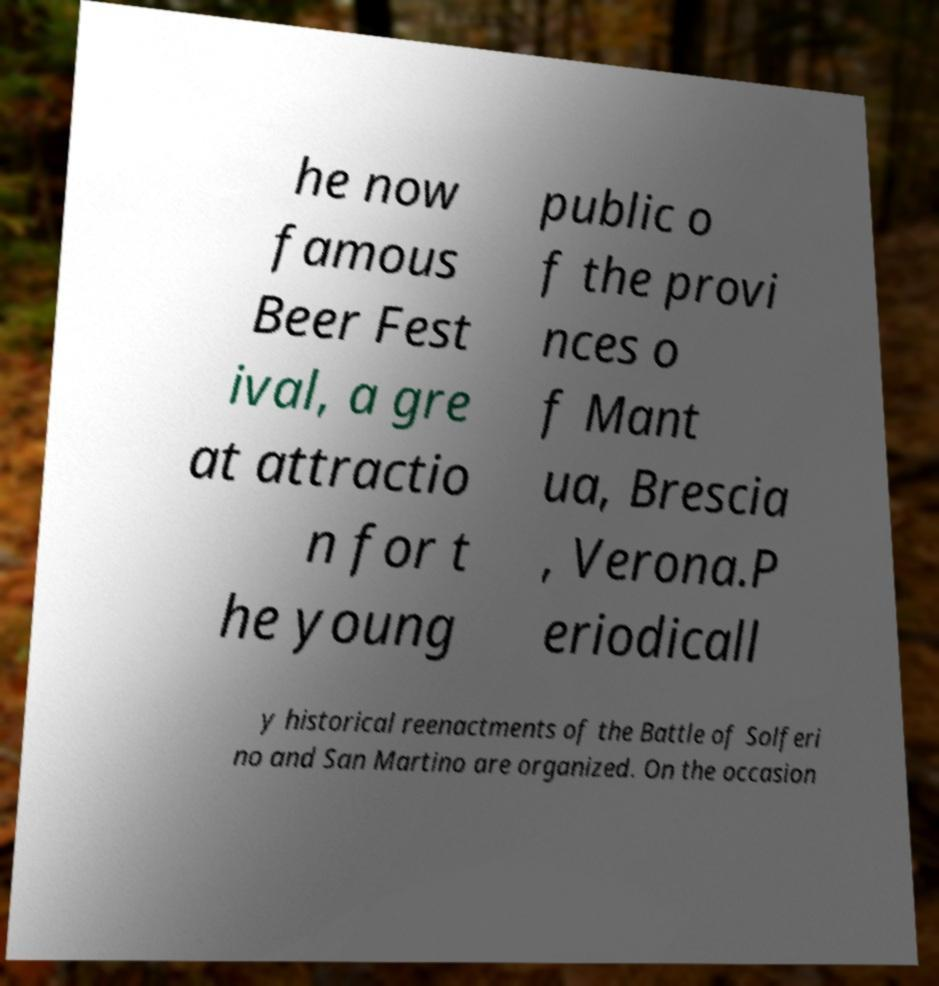There's text embedded in this image that I need extracted. Can you transcribe it verbatim? he now famous Beer Fest ival, a gre at attractio n for t he young public o f the provi nces o f Mant ua, Brescia , Verona.P eriodicall y historical reenactments of the Battle of Solferi no and San Martino are organized. On the occasion 